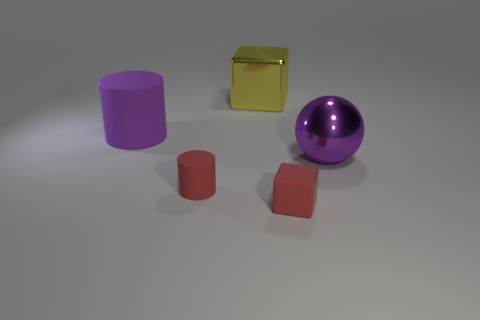What is the shape of the matte thing that is behind the rubber cube and in front of the large purple rubber object?
Your response must be concise. Cylinder. How big is the block that is behind the block that is right of the yellow shiny object?
Make the answer very short. Large. How many other purple matte things are the same shape as the big matte object?
Keep it short and to the point. 0. Does the big matte object have the same color as the shiny sphere?
Keep it short and to the point. Yes. Is there anything else that has the same shape as the large purple shiny object?
Provide a succinct answer. No. Is there a object of the same color as the large sphere?
Offer a very short reply. Yes. Is the cylinder in front of the purple metal thing made of the same material as the large purple object that is left of the metallic cube?
Provide a short and direct response. Yes. What color is the big cylinder?
Your answer should be very brief. Purple. What is the size of the metallic object in front of the rubber cylinder behind the large purple thing in front of the big purple cylinder?
Keep it short and to the point. Large. What number of other objects are there of the same size as the red rubber block?
Your answer should be compact. 1. 